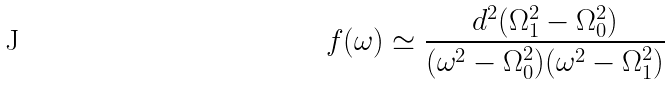Convert formula to latex. <formula><loc_0><loc_0><loc_500><loc_500>f ( \omega ) \simeq \frac { d ^ { 2 } ( \Omega _ { 1 } ^ { 2 } - \Omega _ { 0 } ^ { 2 } ) } { ( \omega ^ { 2 } - \Omega _ { 0 } ^ { 2 } ) ( \omega ^ { 2 } - \Omega _ { 1 } ^ { 2 } ) }</formula> 